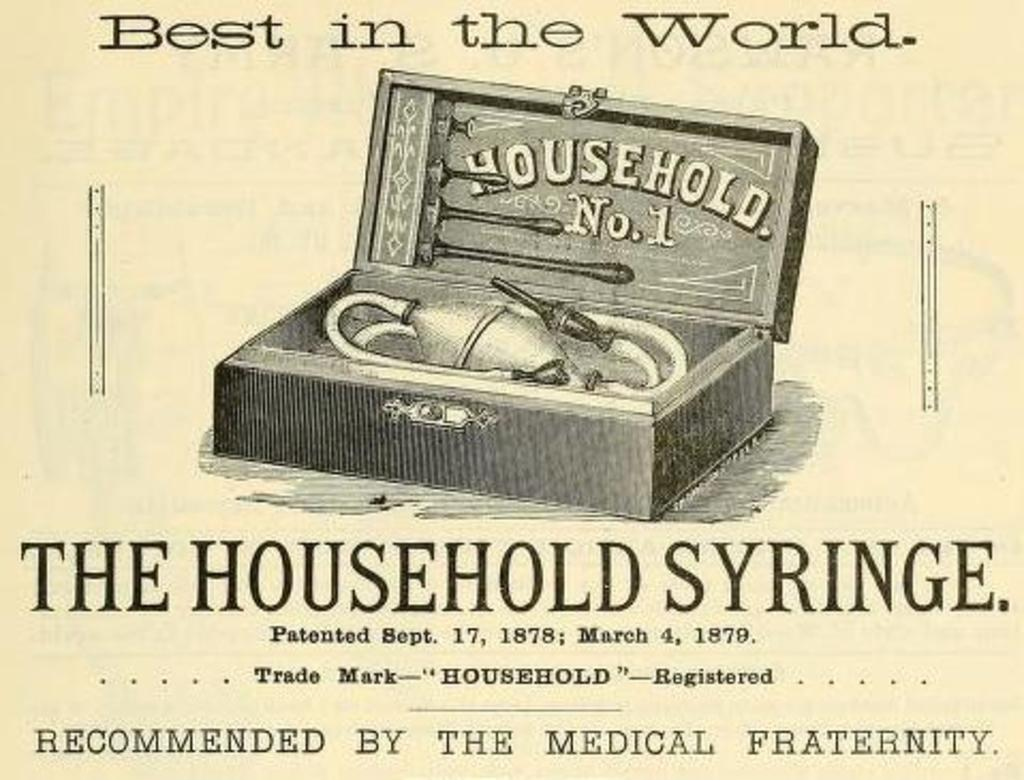What is present in the image that contains information or a message? There is a poster in the image that contains text. What else can be seen on the poster besides the text? The poster has a picture of an object. What type of doll is shown on the poster in the image? There is no doll present on the poster in the image; it contains text and a picture of an object. 